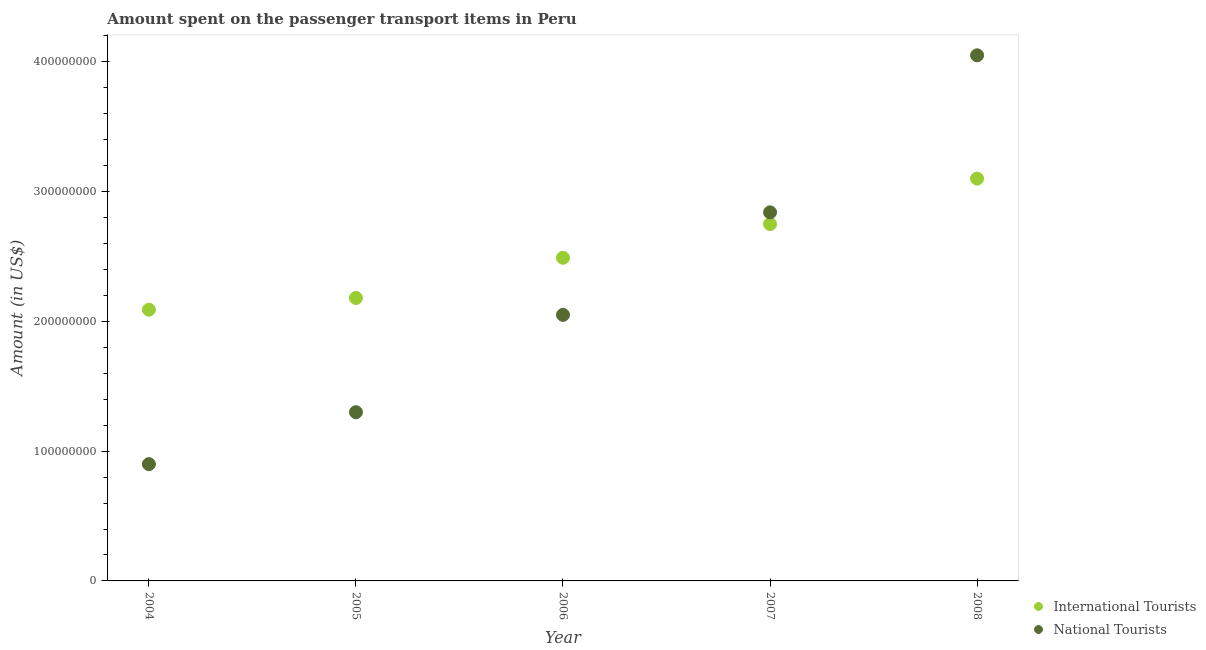What is the amount spent on transport items of international tourists in 2006?
Provide a succinct answer. 2.49e+08. Across all years, what is the maximum amount spent on transport items of international tourists?
Keep it short and to the point. 3.10e+08. Across all years, what is the minimum amount spent on transport items of international tourists?
Your answer should be very brief. 2.09e+08. In which year was the amount spent on transport items of national tourists maximum?
Ensure brevity in your answer.  2008. What is the total amount spent on transport items of national tourists in the graph?
Keep it short and to the point. 1.11e+09. What is the difference between the amount spent on transport items of national tourists in 2004 and that in 2006?
Provide a short and direct response. -1.15e+08. What is the difference between the amount spent on transport items of international tourists in 2007 and the amount spent on transport items of national tourists in 2004?
Offer a terse response. 1.85e+08. What is the average amount spent on transport items of international tourists per year?
Your answer should be compact. 2.52e+08. In the year 2005, what is the difference between the amount spent on transport items of national tourists and amount spent on transport items of international tourists?
Give a very brief answer. -8.80e+07. What is the ratio of the amount spent on transport items of international tourists in 2006 to that in 2008?
Offer a terse response. 0.8. Is the amount spent on transport items of international tourists in 2007 less than that in 2008?
Offer a terse response. Yes. Is the difference between the amount spent on transport items of national tourists in 2005 and 2006 greater than the difference between the amount spent on transport items of international tourists in 2005 and 2006?
Your answer should be compact. No. What is the difference between the highest and the second highest amount spent on transport items of national tourists?
Ensure brevity in your answer.  1.21e+08. What is the difference between the highest and the lowest amount spent on transport items of international tourists?
Offer a very short reply. 1.01e+08. In how many years, is the amount spent on transport items of international tourists greater than the average amount spent on transport items of international tourists taken over all years?
Ensure brevity in your answer.  2. How many years are there in the graph?
Offer a terse response. 5. Does the graph contain grids?
Provide a short and direct response. No. Where does the legend appear in the graph?
Your answer should be very brief. Bottom right. How many legend labels are there?
Provide a short and direct response. 2. How are the legend labels stacked?
Provide a short and direct response. Vertical. What is the title of the graph?
Keep it short and to the point. Amount spent on the passenger transport items in Peru. Does "International Visitors" appear as one of the legend labels in the graph?
Ensure brevity in your answer.  No. What is the label or title of the X-axis?
Offer a very short reply. Year. What is the Amount (in US$) in International Tourists in 2004?
Provide a succinct answer. 2.09e+08. What is the Amount (in US$) of National Tourists in 2004?
Your response must be concise. 9.00e+07. What is the Amount (in US$) in International Tourists in 2005?
Give a very brief answer. 2.18e+08. What is the Amount (in US$) in National Tourists in 2005?
Your response must be concise. 1.30e+08. What is the Amount (in US$) in International Tourists in 2006?
Provide a short and direct response. 2.49e+08. What is the Amount (in US$) in National Tourists in 2006?
Your answer should be compact. 2.05e+08. What is the Amount (in US$) of International Tourists in 2007?
Offer a very short reply. 2.75e+08. What is the Amount (in US$) in National Tourists in 2007?
Offer a very short reply. 2.84e+08. What is the Amount (in US$) of International Tourists in 2008?
Your response must be concise. 3.10e+08. What is the Amount (in US$) in National Tourists in 2008?
Give a very brief answer. 4.05e+08. Across all years, what is the maximum Amount (in US$) in International Tourists?
Make the answer very short. 3.10e+08. Across all years, what is the maximum Amount (in US$) in National Tourists?
Give a very brief answer. 4.05e+08. Across all years, what is the minimum Amount (in US$) of International Tourists?
Keep it short and to the point. 2.09e+08. Across all years, what is the minimum Amount (in US$) in National Tourists?
Offer a very short reply. 9.00e+07. What is the total Amount (in US$) of International Tourists in the graph?
Your answer should be compact. 1.26e+09. What is the total Amount (in US$) of National Tourists in the graph?
Offer a terse response. 1.11e+09. What is the difference between the Amount (in US$) of International Tourists in 2004 and that in 2005?
Provide a short and direct response. -9.00e+06. What is the difference between the Amount (in US$) in National Tourists in 2004 and that in 2005?
Offer a very short reply. -4.00e+07. What is the difference between the Amount (in US$) in International Tourists in 2004 and that in 2006?
Make the answer very short. -4.00e+07. What is the difference between the Amount (in US$) in National Tourists in 2004 and that in 2006?
Offer a terse response. -1.15e+08. What is the difference between the Amount (in US$) in International Tourists in 2004 and that in 2007?
Your answer should be compact. -6.60e+07. What is the difference between the Amount (in US$) in National Tourists in 2004 and that in 2007?
Keep it short and to the point. -1.94e+08. What is the difference between the Amount (in US$) in International Tourists in 2004 and that in 2008?
Provide a succinct answer. -1.01e+08. What is the difference between the Amount (in US$) in National Tourists in 2004 and that in 2008?
Make the answer very short. -3.15e+08. What is the difference between the Amount (in US$) in International Tourists in 2005 and that in 2006?
Keep it short and to the point. -3.10e+07. What is the difference between the Amount (in US$) in National Tourists in 2005 and that in 2006?
Ensure brevity in your answer.  -7.50e+07. What is the difference between the Amount (in US$) in International Tourists in 2005 and that in 2007?
Provide a short and direct response. -5.70e+07. What is the difference between the Amount (in US$) in National Tourists in 2005 and that in 2007?
Your answer should be very brief. -1.54e+08. What is the difference between the Amount (in US$) in International Tourists in 2005 and that in 2008?
Offer a terse response. -9.20e+07. What is the difference between the Amount (in US$) of National Tourists in 2005 and that in 2008?
Offer a terse response. -2.75e+08. What is the difference between the Amount (in US$) in International Tourists in 2006 and that in 2007?
Your response must be concise. -2.60e+07. What is the difference between the Amount (in US$) in National Tourists in 2006 and that in 2007?
Your response must be concise. -7.90e+07. What is the difference between the Amount (in US$) in International Tourists in 2006 and that in 2008?
Offer a terse response. -6.10e+07. What is the difference between the Amount (in US$) in National Tourists in 2006 and that in 2008?
Provide a short and direct response. -2.00e+08. What is the difference between the Amount (in US$) of International Tourists in 2007 and that in 2008?
Offer a terse response. -3.50e+07. What is the difference between the Amount (in US$) of National Tourists in 2007 and that in 2008?
Ensure brevity in your answer.  -1.21e+08. What is the difference between the Amount (in US$) of International Tourists in 2004 and the Amount (in US$) of National Tourists in 2005?
Make the answer very short. 7.90e+07. What is the difference between the Amount (in US$) of International Tourists in 2004 and the Amount (in US$) of National Tourists in 2006?
Provide a succinct answer. 4.00e+06. What is the difference between the Amount (in US$) of International Tourists in 2004 and the Amount (in US$) of National Tourists in 2007?
Keep it short and to the point. -7.50e+07. What is the difference between the Amount (in US$) of International Tourists in 2004 and the Amount (in US$) of National Tourists in 2008?
Provide a succinct answer. -1.96e+08. What is the difference between the Amount (in US$) in International Tourists in 2005 and the Amount (in US$) in National Tourists in 2006?
Provide a succinct answer. 1.30e+07. What is the difference between the Amount (in US$) in International Tourists in 2005 and the Amount (in US$) in National Tourists in 2007?
Offer a terse response. -6.60e+07. What is the difference between the Amount (in US$) in International Tourists in 2005 and the Amount (in US$) in National Tourists in 2008?
Your answer should be compact. -1.87e+08. What is the difference between the Amount (in US$) in International Tourists in 2006 and the Amount (in US$) in National Tourists in 2007?
Offer a very short reply. -3.50e+07. What is the difference between the Amount (in US$) in International Tourists in 2006 and the Amount (in US$) in National Tourists in 2008?
Your answer should be very brief. -1.56e+08. What is the difference between the Amount (in US$) in International Tourists in 2007 and the Amount (in US$) in National Tourists in 2008?
Provide a short and direct response. -1.30e+08. What is the average Amount (in US$) of International Tourists per year?
Ensure brevity in your answer.  2.52e+08. What is the average Amount (in US$) in National Tourists per year?
Offer a terse response. 2.23e+08. In the year 2004, what is the difference between the Amount (in US$) in International Tourists and Amount (in US$) in National Tourists?
Give a very brief answer. 1.19e+08. In the year 2005, what is the difference between the Amount (in US$) in International Tourists and Amount (in US$) in National Tourists?
Your answer should be compact. 8.80e+07. In the year 2006, what is the difference between the Amount (in US$) of International Tourists and Amount (in US$) of National Tourists?
Make the answer very short. 4.40e+07. In the year 2007, what is the difference between the Amount (in US$) of International Tourists and Amount (in US$) of National Tourists?
Offer a terse response. -9.00e+06. In the year 2008, what is the difference between the Amount (in US$) in International Tourists and Amount (in US$) in National Tourists?
Your answer should be compact. -9.50e+07. What is the ratio of the Amount (in US$) in International Tourists in 2004 to that in 2005?
Make the answer very short. 0.96. What is the ratio of the Amount (in US$) in National Tourists in 2004 to that in 2005?
Your answer should be compact. 0.69. What is the ratio of the Amount (in US$) in International Tourists in 2004 to that in 2006?
Make the answer very short. 0.84. What is the ratio of the Amount (in US$) of National Tourists in 2004 to that in 2006?
Offer a very short reply. 0.44. What is the ratio of the Amount (in US$) of International Tourists in 2004 to that in 2007?
Ensure brevity in your answer.  0.76. What is the ratio of the Amount (in US$) of National Tourists in 2004 to that in 2007?
Your answer should be very brief. 0.32. What is the ratio of the Amount (in US$) in International Tourists in 2004 to that in 2008?
Provide a succinct answer. 0.67. What is the ratio of the Amount (in US$) in National Tourists in 2004 to that in 2008?
Offer a terse response. 0.22. What is the ratio of the Amount (in US$) of International Tourists in 2005 to that in 2006?
Your response must be concise. 0.88. What is the ratio of the Amount (in US$) of National Tourists in 2005 to that in 2006?
Make the answer very short. 0.63. What is the ratio of the Amount (in US$) of International Tourists in 2005 to that in 2007?
Ensure brevity in your answer.  0.79. What is the ratio of the Amount (in US$) of National Tourists in 2005 to that in 2007?
Your response must be concise. 0.46. What is the ratio of the Amount (in US$) of International Tourists in 2005 to that in 2008?
Provide a succinct answer. 0.7. What is the ratio of the Amount (in US$) of National Tourists in 2005 to that in 2008?
Offer a terse response. 0.32. What is the ratio of the Amount (in US$) of International Tourists in 2006 to that in 2007?
Make the answer very short. 0.91. What is the ratio of the Amount (in US$) in National Tourists in 2006 to that in 2007?
Keep it short and to the point. 0.72. What is the ratio of the Amount (in US$) in International Tourists in 2006 to that in 2008?
Make the answer very short. 0.8. What is the ratio of the Amount (in US$) in National Tourists in 2006 to that in 2008?
Your response must be concise. 0.51. What is the ratio of the Amount (in US$) in International Tourists in 2007 to that in 2008?
Ensure brevity in your answer.  0.89. What is the ratio of the Amount (in US$) of National Tourists in 2007 to that in 2008?
Offer a very short reply. 0.7. What is the difference between the highest and the second highest Amount (in US$) in International Tourists?
Your response must be concise. 3.50e+07. What is the difference between the highest and the second highest Amount (in US$) of National Tourists?
Your response must be concise. 1.21e+08. What is the difference between the highest and the lowest Amount (in US$) of International Tourists?
Keep it short and to the point. 1.01e+08. What is the difference between the highest and the lowest Amount (in US$) of National Tourists?
Your response must be concise. 3.15e+08. 